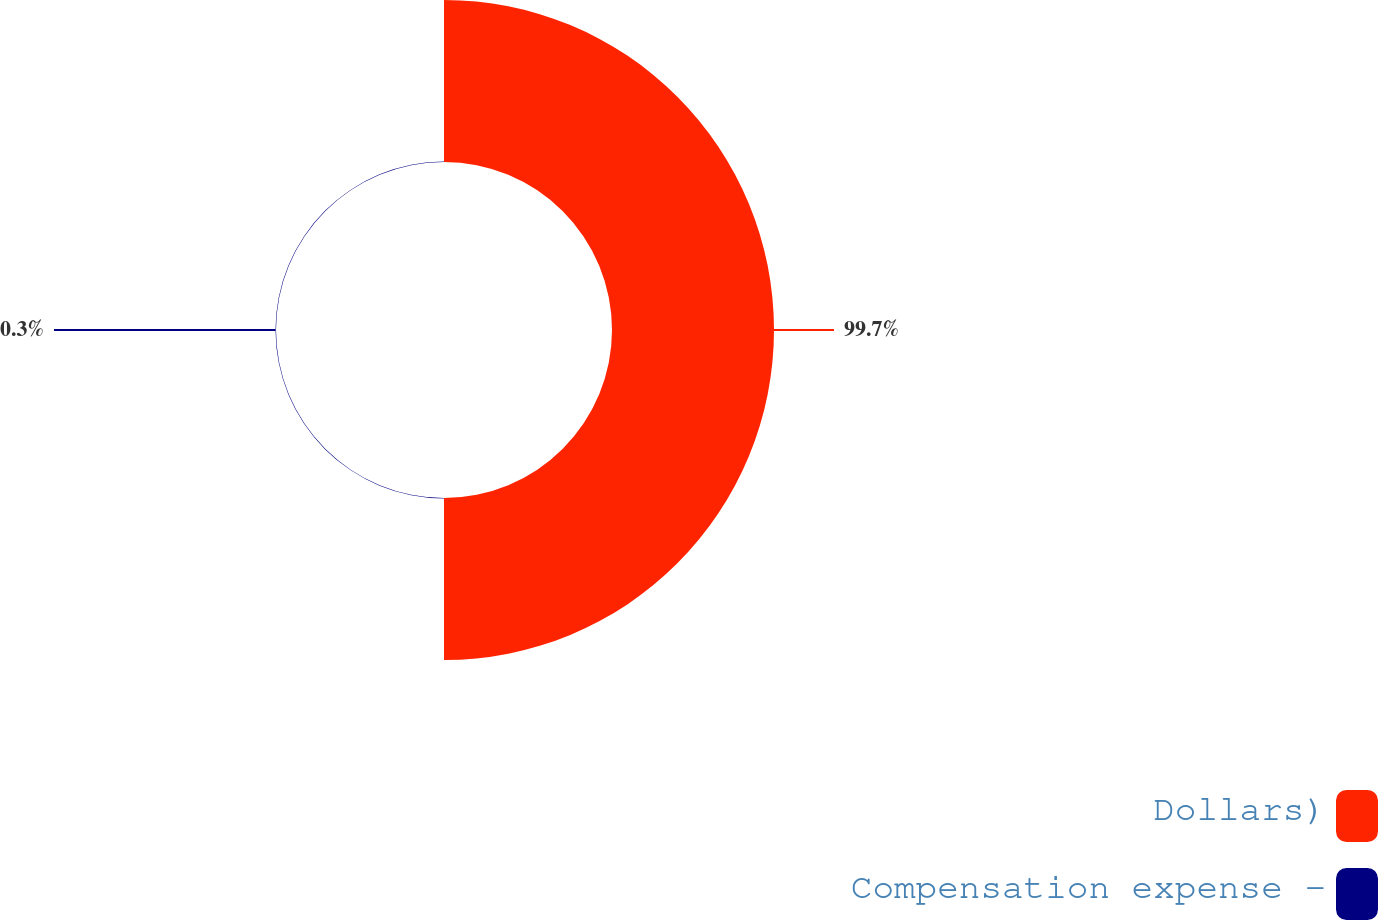Convert chart to OTSL. <chart><loc_0><loc_0><loc_500><loc_500><pie_chart><fcel>Dollars)<fcel>Compensation expense -<nl><fcel>99.7%<fcel>0.3%<nl></chart> 